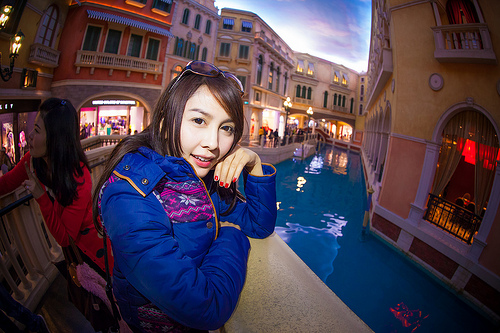<image>
Can you confirm if the girl is on the wall? Yes. Looking at the image, I can see the girl is positioned on top of the wall, with the wall providing support. 